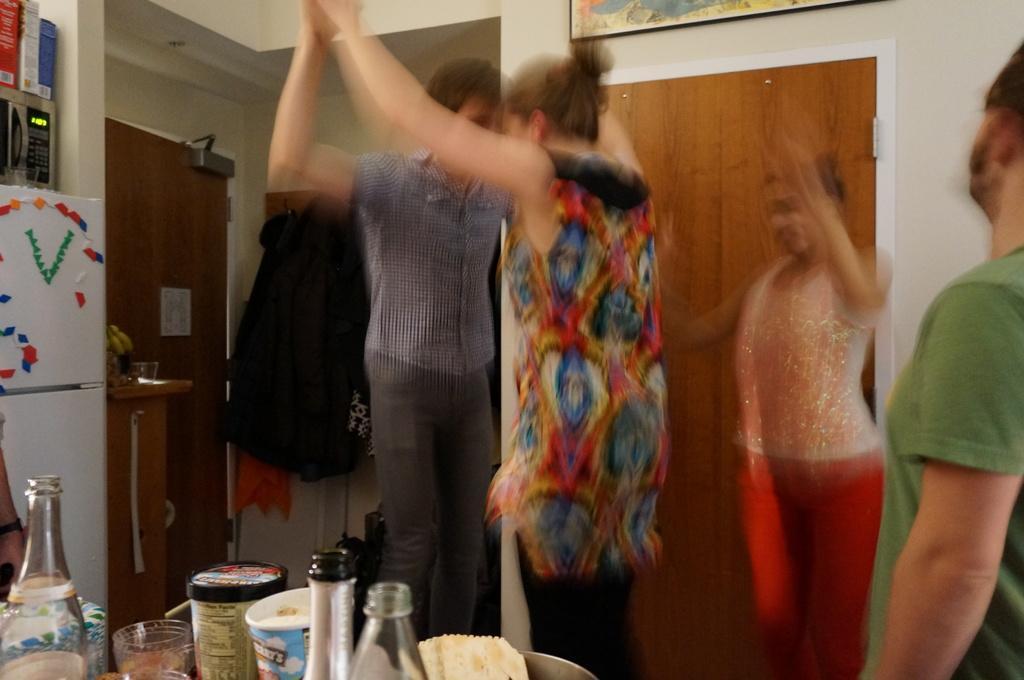Describe this image in one or two sentences. In this picture we can see people. We can see bottles, glasses and objects on the platform. We can see stickers on refrigerator, beside the refrigerator we can see glass and objects on the wooden platform and above the refrigerator we can see boxes on oven. In the background we can see doors and frame on the wall. 